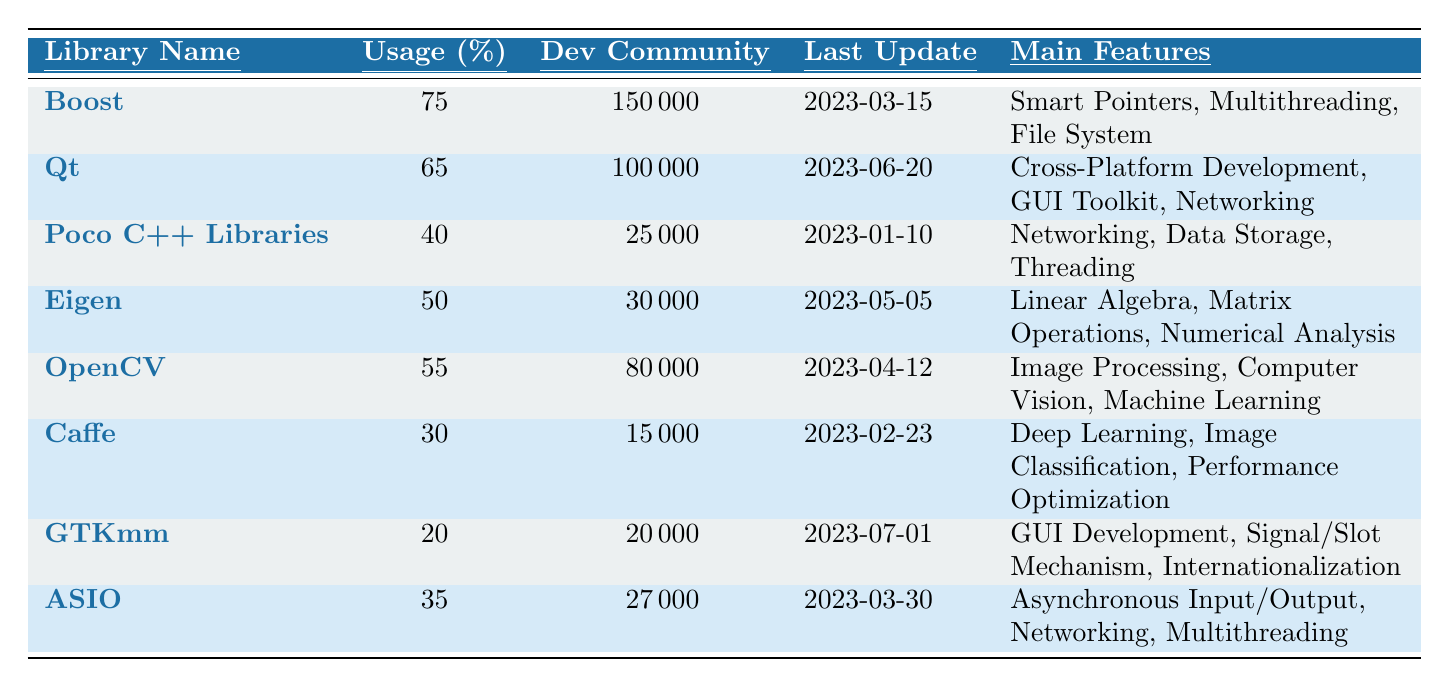What is the usage percentage of the Qt library? The table shows that the usage percentage for the Qt library is listed directly in the second column under the respective row. This value is 65%.
Answer: 65% Which library has the largest developer community? By examining the "Dev Community" column in the table, we see that Boost has the largest community size listed as 150,000.
Answer: Boost What are the main features of OpenCV? The main features of OpenCV can be found in the last column of its row, which lists "Image Processing, Computer Vision, Machine Learning."
Answer: Image Processing, Computer Vision, Machine Learning Is the last update date for Caffe later than that of Poco C++ Libraries? The table shows that Caffe's last update was on 2023-02-23 and Poco C++ Libraries' last update was on 2023-01-10. Since February 23 is later than January 10, the statement is true.
Answer: Yes What is the average usage percentage of all libraries listed? To find the average, sum all usage percentages: (75 + 65 + 40 + 50 + 55 + 30 + 20 + 35) = 370. Since there are 8 libraries, calculate the average: 370 / 8 = 46.25.
Answer: 46.25 Which libraries have a usage percentage below 50%? By reviewing the usage percentages, we find that Poco C++ Libraries (40%), Caffe (30%), GTKmm (20%), and ASIO (35%) all fall below 50%.
Answer: Poco C++ Libraries, Caffe, GTKmm, ASIO What is the difference in developer community size between Boost and GTKmm? The community sizes for Boost and GTKmm are 150,000 and 20,000 respectively. Subtract the smaller value from the larger: 150,000 - 20,000 = 130,000.
Answer: 130,000 What is the last update date of the library with the lowest usage percentage? The library with the lowest usage percentage is GTKmm at 20%, and its last update date, according to the table, is 2023-07-01.
Answer: 2023-07-01 Which library has both asynchronous input/output and multithreading as features? Looking through the "Main Features" column, ASIO is the only library that includes both "Asynchronous Input/Output" and "Multithreading."
Answer: ASIO Is there any library that specializes solely in GUI development? The only library that prominently mentions GUI development in its features is GTKmm. However, since it also mentions Internationalization and Signal/Slot Mechanism, it does not specialize solely in GUI development. Therefore, the answer is false.
Answer: No 